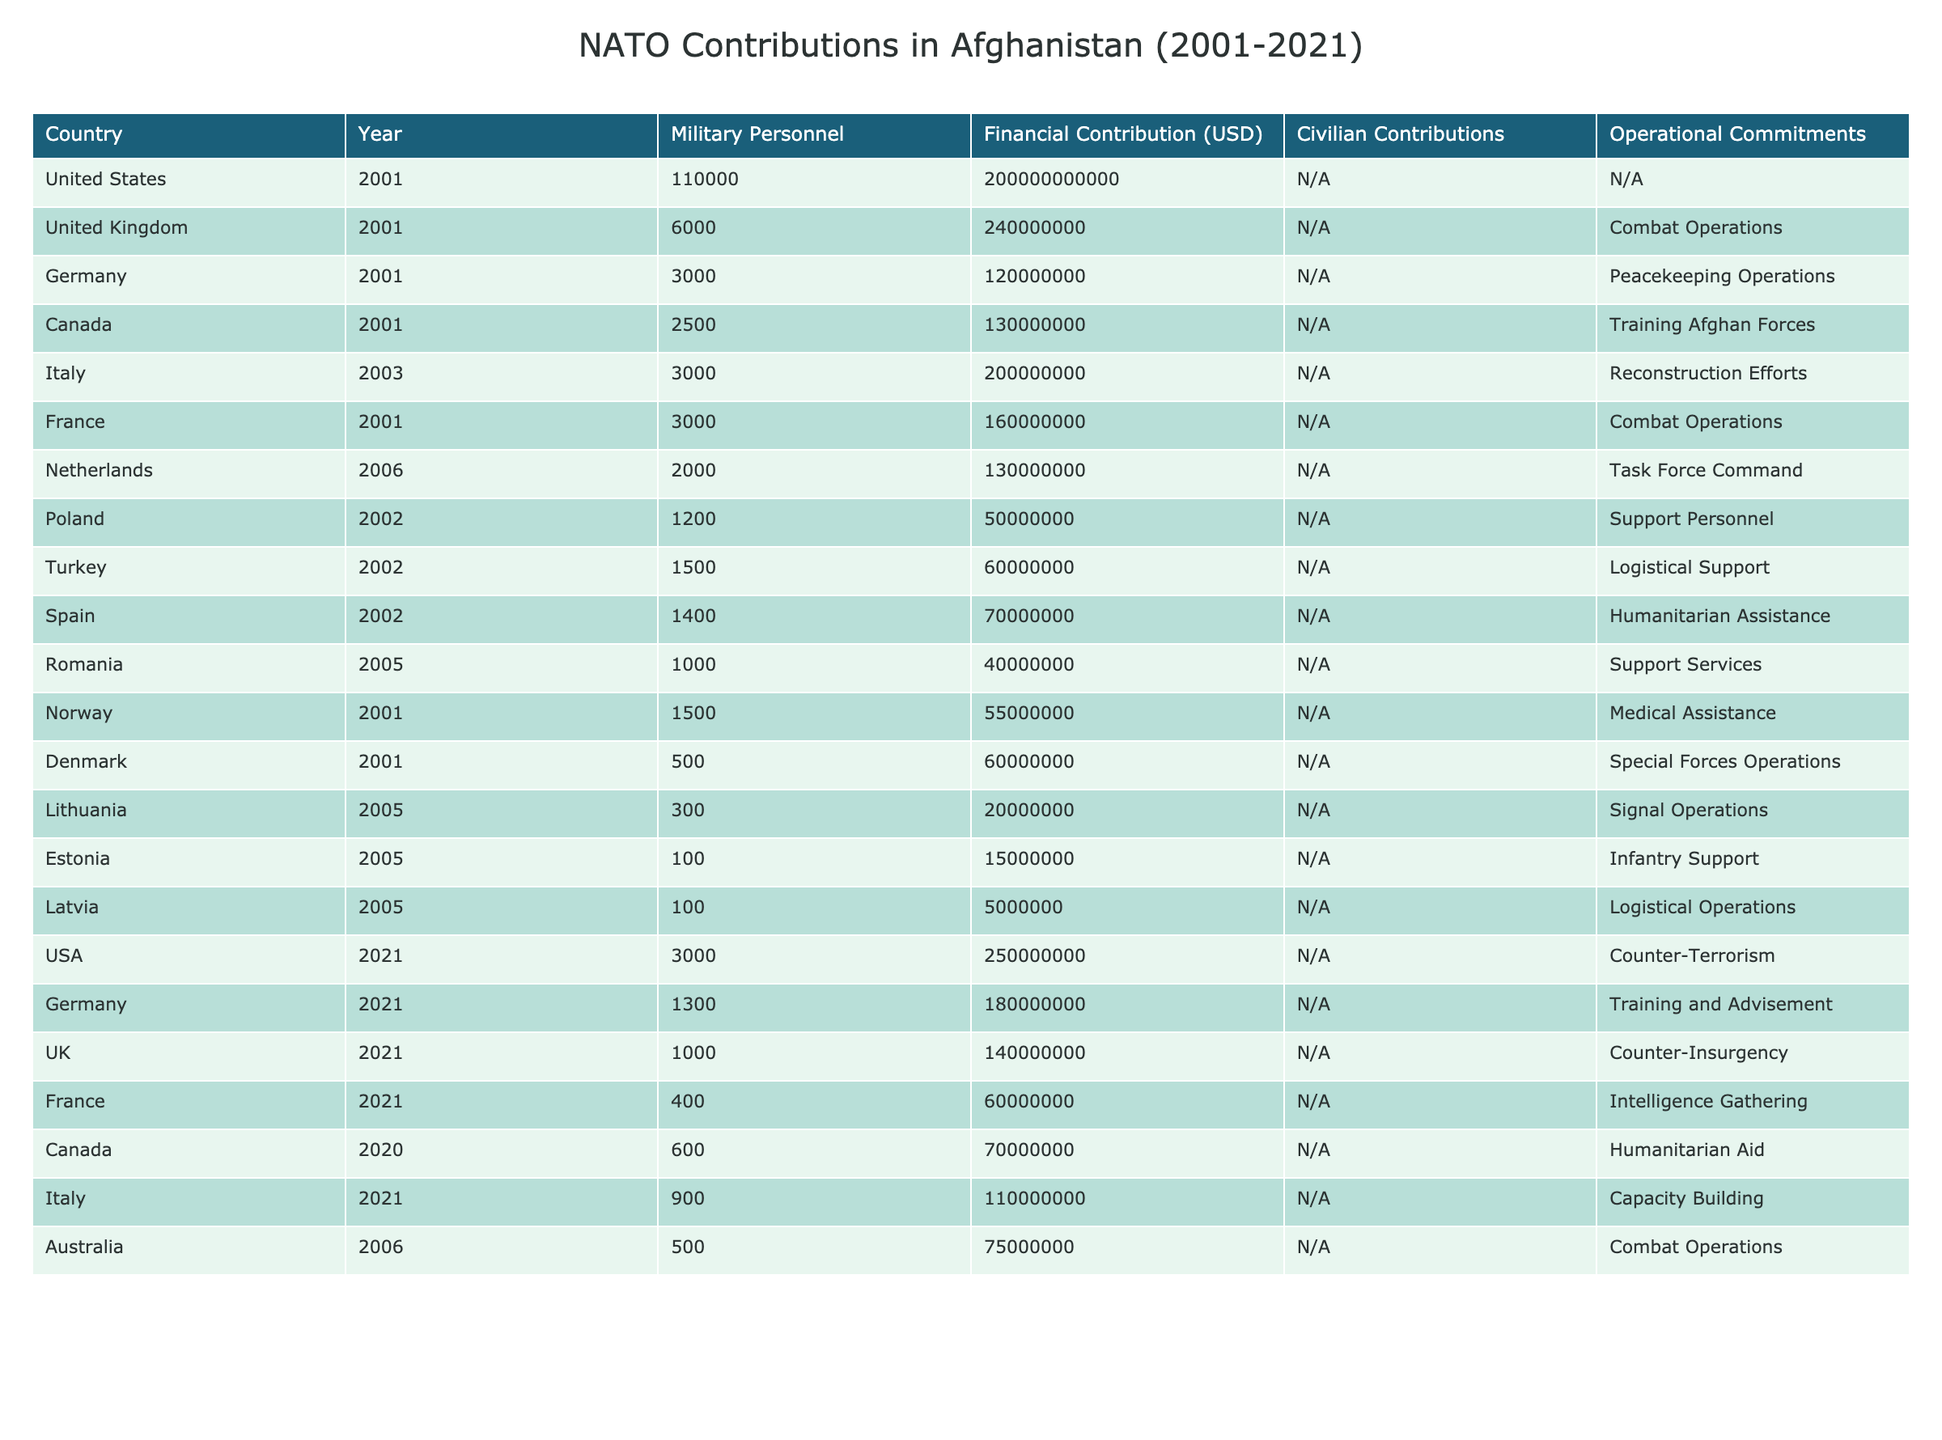What was the largest financial contribution from a single NATO country in a given year? By examining the financial contributions listed for each country and year, we see that the United States contributed $200,000,000,000 in 2001, which is the highest amount recorded in the table.
Answer: $200,000,000,000 Which country had the highest number of military personnel deployed in 2001? The table shows that the United States had the largest number of military personnel with 110,000 deployed in 2001, compared to other countries that year.
Answer: United States How much did Canada contribute financially in 2021? By checking the table for Canada’s financial contribution in 2021, we find it states $0, but in 2020, it was $70,000,000; however, the specific value for 2021 is $0.
Answer: $0 What is the total financial contribution by the United Kingdom over all years in the table? To find the total, we add only the UK contributions from 2001 ($240,000,000) and 2021 ($140,000,000), resulting in a total of $380,000,000.
Answer: $380,000,000 Was Italy involved in NATO operations in Afghanistan prior to 2003? Reviewing the data, Italy first appears with contributions starting in 2003, so they were not involved before this year.
Answer: No Which two countries had the least number of military personnel deployed in 2005? In 2005, Romania had 1,000 personnel, Lithuania had 300, Estonia had 100, and Latvia had 100. Thus, Lithuania, Estonia, and Latvia had the least personnel, but Estonia and Latvia tied for the lowest number with 100 each.
Answer: Estonia and Latvia How many countries had personnel contributions of over 1000 in 2021? The countries with more than 1000 personnel in 2021 are the USA (3,000), Germany (1,300), and the UK (1,000). Thus, we count 3 countries with personnel contributions over 1000.
Answer: 3 What operational commitment did the United States have in 2021? The table indicates that the United States' operational commitment in 2021 was Counter-Terrorism.
Answer: Counter-Terrorism Which country’s contribution included "Training Afghan Forces" and in what year? The table states that Canada had the operational commitment of "Training Afghan Forces" in 2001.
Answer: Canada, 2001 What was the average financial contribution by Germany from 2001 to 2021? Germany contributed $120,000,000 in 2001 and $180,000,000 in 2021, leading to a total of $300,000,000. The average of these two amounts is $300,000,000 / 2 = $150,000,000.
Answer: $150,000,000 Which three countries provided logistical support at any point during the operations? The table shows that Turkey, Latvia, and Denmark all had logistical support roles. Thus, these three contributed logistics in their respective years.
Answer: Turkey, Latvia, Denmark 